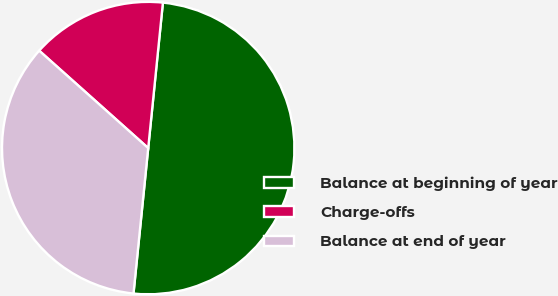Convert chart to OTSL. <chart><loc_0><loc_0><loc_500><loc_500><pie_chart><fcel>Balance at beginning of year<fcel>Charge-offs<fcel>Balance at end of year<nl><fcel>50.0%<fcel>15.0%<fcel>35.0%<nl></chart> 